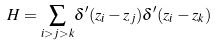<formula> <loc_0><loc_0><loc_500><loc_500>H = { \sum _ { i > j > k } } \delta ^ { \prime } ( { z _ { i } } - { z _ { j } } ) \delta ^ { \prime } ( { z _ { i } } - { z _ { k } } )</formula> 